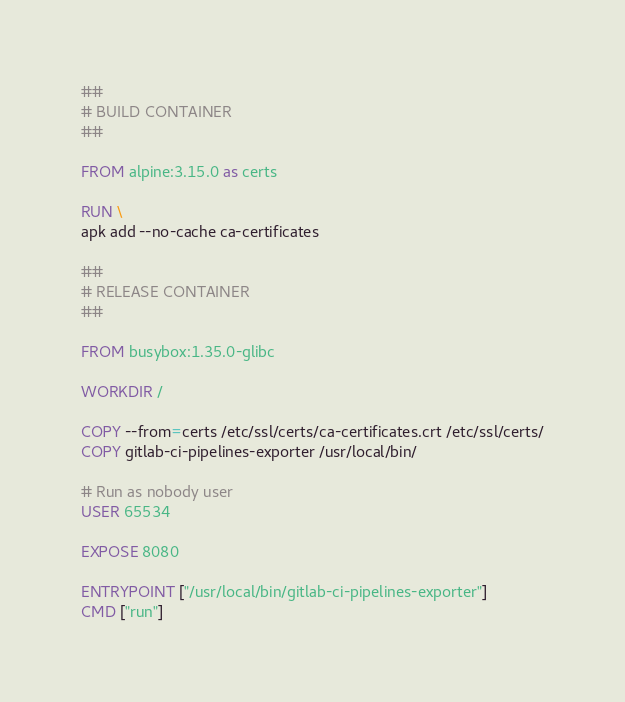Convert code to text. <code><loc_0><loc_0><loc_500><loc_500><_Dockerfile_>##
# BUILD CONTAINER
##

FROM alpine:3.15.0 as certs

RUN \
apk add --no-cache ca-certificates

##
# RELEASE CONTAINER
##

FROM busybox:1.35.0-glibc

WORKDIR /

COPY --from=certs /etc/ssl/certs/ca-certificates.crt /etc/ssl/certs/
COPY gitlab-ci-pipelines-exporter /usr/local/bin/

# Run as nobody user
USER 65534

EXPOSE 8080

ENTRYPOINT ["/usr/local/bin/gitlab-ci-pipelines-exporter"]
CMD ["run"]
</code> 